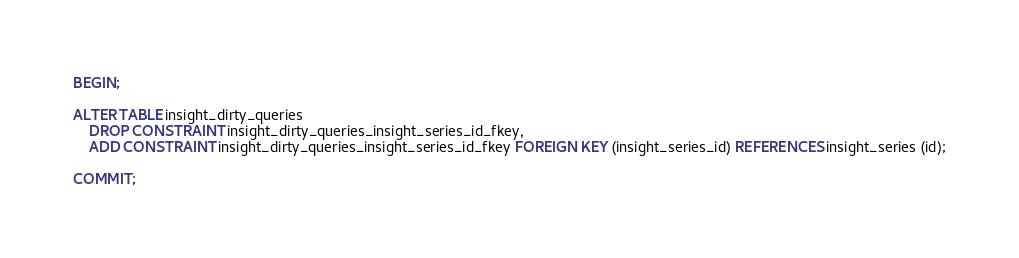<code> <loc_0><loc_0><loc_500><loc_500><_SQL_>BEGIN;

ALTER TABLE insight_dirty_queries
    DROP CONSTRAINT insight_dirty_queries_insight_series_id_fkey,
    ADD CONSTRAINT insight_dirty_queries_insight_series_id_fkey FOREIGN KEY (insight_series_id) REFERENCES insight_series (id);

COMMIT;
</code> 